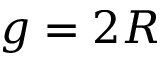Convert formula to latex. <formula><loc_0><loc_0><loc_500><loc_500>g = 2 R</formula> 